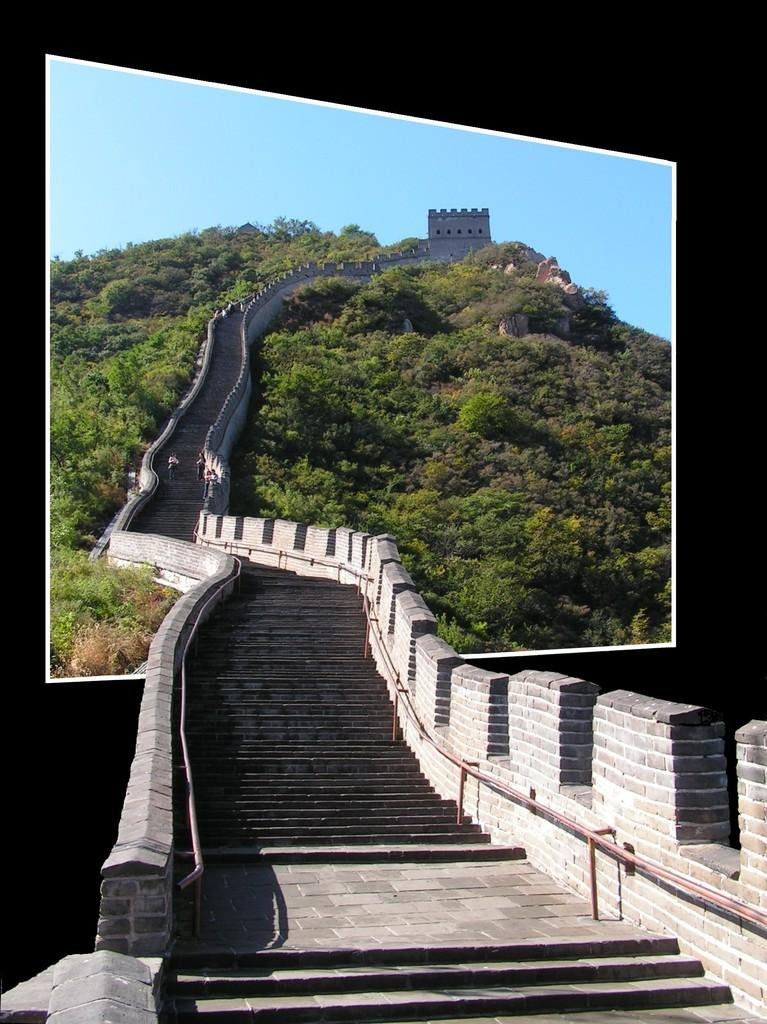What type of architectural feature can be seen in the image? There are steps in the image. What natural elements are present in the image? There are trees and a hill in the image. What is visible in the background of the image? The sky is visible in the background of the image. Where is the bed located in the image? There is no bed present in the image. What type of scale can be seen on the hill in the image? There is no scale present in the image. 